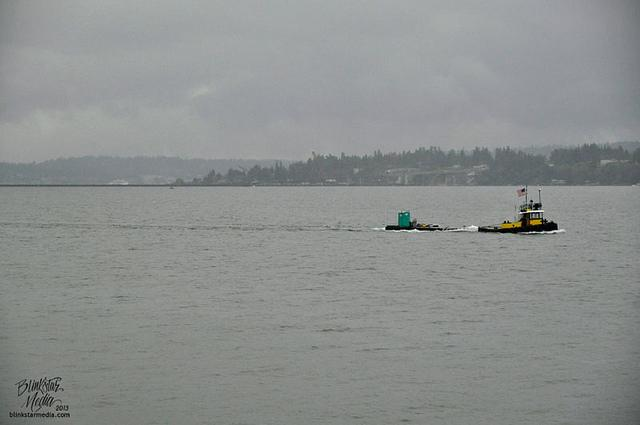The green object on the smaller boat is used as what?

Choices:
A) cabin
B) restroom
C) dining
D) kitchen restroom 